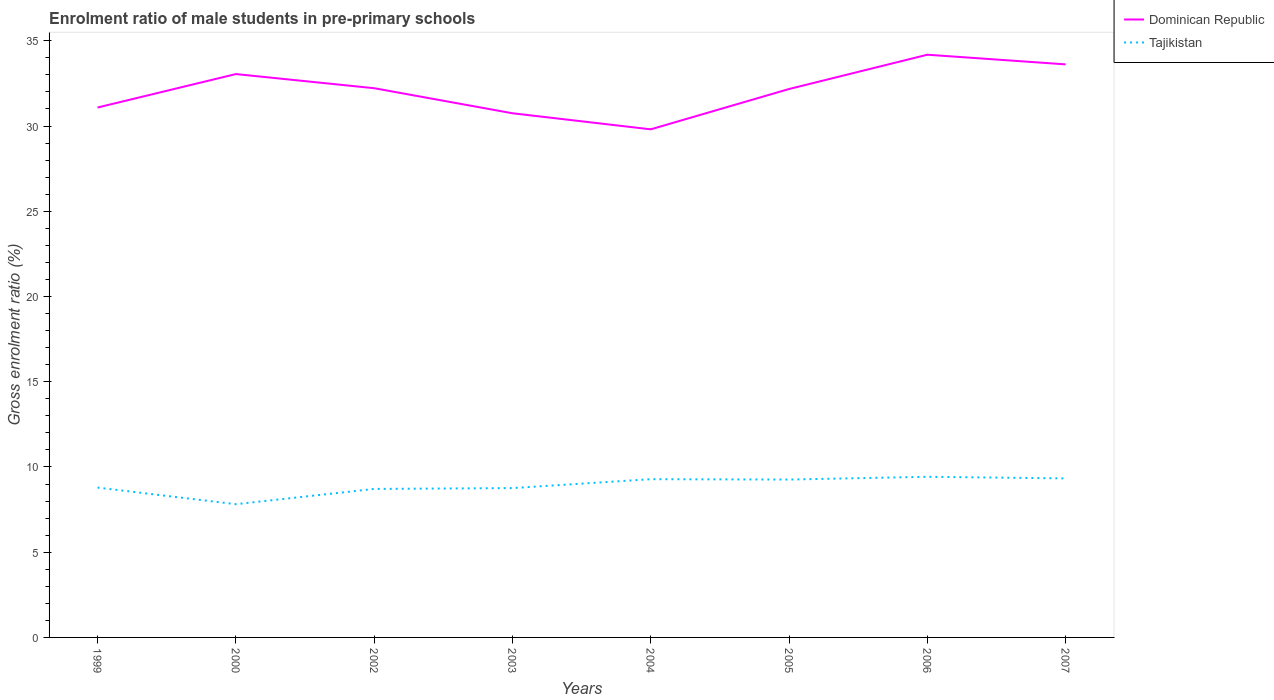Is the number of lines equal to the number of legend labels?
Provide a short and direct response. Yes. Across all years, what is the maximum enrolment ratio of male students in pre-primary schools in Tajikistan?
Offer a terse response. 7.82. What is the total enrolment ratio of male students in pre-primary schools in Dominican Republic in the graph?
Ensure brevity in your answer.  -2.01. What is the difference between the highest and the second highest enrolment ratio of male students in pre-primary schools in Tajikistan?
Keep it short and to the point. 1.61. What is the difference between the highest and the lowest enrolment ratio of male students in pre-primary schools in Dominican Republic?
Your answer should be compact. 5. Is the enrolment ratio of male students in pre-primary schools in Tajikistan strictly greater than the enrolment ratio of male students in pre-primary schools in Dominican Republic over the years?
Ensure brevity in your answer.  Yes. How many years are there in the graph?
Keep it short and to the point. 8. Does the graph contain grids?
Make the answer very short. No. How many legend labels are there?
Your answer should be compact. 2. What is the title of the graph?
Your response must be concise. Enrolment ratio of male students in pre-primary schools. Does "Bahamas" appear as one of the legend labels in the graph?
Offer a terse response. No. What is the Gross enrolment ratio (%) of Dominican Republic in 1999?
Your response must be concise. 31.09. What is the Gross enrolment ratio (%) of Tajikistan in 1999?
Your response must be concise. 8.79. What is the Gross enrolment ratio (%) in Dominican Republic in 2000?
Your answer should be very brief. 33.05. What is the Gross enrolment ratio (%) of Tajikistan in 2000?
Make the answer very short. 7.82. What is the Gross enrolment ratio (%) in Dominican Republic in 2002?
Offer a terse response. 32.22. What is the Gross enrolment ratio (%) in Tajikistan in 2002?
Offer a very short reply. 8.71. What is the Gross enrolment ratio (%) of Dominican Republic in 2003?
Ensure brevity in your answer.  30.75. What is the Gross enrolment ratio (%) of Tajikistan in 2003?
Ensure brevity in your answer.  8.76. What is the Gross enrolment ratio (%) in Dominican Republic in 2004?
Your answer should be very brief. 29.81. What is the Gross enrolment ratio (%) of Tajikistan in 2004?
Ensure brevity in your answer.  9.28. What is the Gross enrolment ratio (%) of Dominican Republic in 2005?
Offer a terse response. 32.17. What is the Gross enrolment ratio (%) of Tajikistan in 2005?
Your answer should be compact. 9.26. What is the Gross enrolment ratio (%) in Dominican Republic in 2006?
Your response must be concise. 34.18. What is the Gross enrolment ratio (%) in Tajikistan in 2006?
Provide a succinct answer. 9.42. What is the Gross enrolment ratio (%) of Dominican Republic in 2007?
Keep it short and to the point. 33.62. What is the Gross enrolment ratio (%) in Tajikistan in 2007?
Give a very brief answer. 9.33. Across all years, what is the maximum Gross enrolment ratio (%) of Dominican Republic?
Keep it short and to the point. 34.18. Across all years, what is the maximum Gross enrolment ratio (%) of Tajikistan?
Your response must be concise. 9.42. Across all years, what is the minimum Gross enrolment ratio (%) in Dominican Republic?
Make the answer very short. 29.81. Across all years, what is the minimum Gross enrolment ratio (%) of Tajikistan?
Your response must be concise. 7.82. What is the total Gross enrolment ratio (%) in Dominican Republic in the graph?
Offer a terse response. 256.88. What is the total Gross enrolment ratio (%) in Tajikistan in the graph?
Offer a very short reply. 71.37. What is the difference between the Gross enrolment ratio (%) in Dominican Republic in 1999 and that in 2000?
Your answer should be very brief. -1.96. What is the difference between the Gross enrolment ratio (%) in Tajikistan in 1999 and that in 2000?
Ensure brevity in your answer.  0.97. What is the difference between the Gross enrolment ratio (%) of Dominican Republic in 1999 and that in 2002?
Your response must be concise. -1.13. What is the difference between the Gross enrolment ratio (%) of Tajikistan in 1999 and that in 2002?
Offer a terse response. 0.08. What is the difference between the Gross enrolment ratio (%) of Dominican Republic in 1999 and that in 2003?
Your response must be concise. 0.34. What is the difference between the Gross enrolment ratio (%) of Tajikistan in 1999 and that in 2003?
Provide a short and direct response. 0.03. What is the difference between the Gross enrolment ratio (%) of Dominican Republic in 1999 and that in 2004?
Your answer should be compact. 1.28. What is the difference between the Gross enrolment ratio (%) of Tajikistan in 1999 and that in 2004?
Provide a short and direct response. -0.49. What is the difference between the Gross enrolment ratio (%) of Dominican Republic in 1999 and that in 2005?
Make the answer very short. -1.09. What is the difference between the Gross enrolment ratio (%) in Tajikistan in 1999 and that in 2005?
Provide a succinct answer. -0.47. What is the difference between the Gross enrolment ratio (%) of Dominican Republic in 1999 and that in 2006?
Offer a terse response. -3.1. What is the difference between the Gross enrolment ratio (%) of Tajikistan in 1999 and that in 2006?
Provide a succinct answer. -0.63. What is the difference between the Gross enrolment ratio (%) of Dominican Republic in 1999 and that in 2007?
Ensure brevity in your answer.  -2.53. What is the difference between the Gross enrolment ratio (%) of Tajikistan in 1999 and that in 2007?
Offer a terse response. -0.54. What is the difference between the Gross enrolment ratio (%) in Dominican Republic in 2000 and that in 2002?
Offer a terse response. 0.83. What is the difference between the Gross enrolment ratio (%) of Tajikistan in 2000 and that in 2002?
Offer a very short reply. -0.9. What is the difference between the Gross enrolment ratio (%) of Dominican Republic in 2000 and that in 2003?
Keep it short and to the point. 2.3. What is the difference between the Gross enrolment ratio (%) of Tajikistan in 2000 and that in 2003?
Offer a very short reply. -0.94. What is the difference between the Gross enrolment ratio (%) in Dominican Republic in 2000 and that in 2004?
Give a very brief answer. 3.24. What is the difference between the Gross enrolment ratio (%) of Tajikistan in 2000 and that in 2004?
Give a very brief answer. -1.47. What is the difference between the Gross enrolment ratio (%) in Dominican Republic in 2000 and that in 2005?
Ensure brevity in your answer.  0.88. What is the difference between the Gross enrolment ratio (%) of Tajikistan in 2000 and that in 2005?
Ensure brevity in your answer.  -1.45. What is the difference between the Gross enrolment ratio (%) of Dominican Republic in 2000 and that in 2006?
Provide a succinct answer. -1.14. What is the difference between the Gross enrolment ratio (%) in Tajikistan in 2000 and that in 2006?
Offer a terse response. -1.61. What is the difference between the Gross enrolment ratio (%) of Dominican Republic in 2000 and that in 2007?
Your response must be concise. -0.57. What is the difference between the Gross enrolment ratio (%) in Tajikistan in 2000 and that in 2007?
Offer a terse response. -1.51. What is the difference between the Gross enrolment ratio (%) in Dominican Republic in 2002 and that in 2003?
Give a very brief answer. 1.47. What is the difference between the Gross enrolment ratio (%) in Tajikistan in 2002 and that in 2003?
Provide a short and direct response. -0.05. What is the difference between the Gross enrolment ratio (%) of Dominican Republic in 2002 and that in 2004?
Give a very brief answer. 2.41. What is the difference between the Gross enrolment ratio (%) of Tajikistan in 2002 and that in 2004?
Keep it short and to the point. -0.57. What is the difference between the Gross enrolment ratio (%) in Dominican Republic in 2002 and that in 2005?
Your answer should be very brief. 0.05. What is the difference between the Gross enrolment ratio (%) in Tajikistan in 2002 and that in 2005?
Offer a terse response. -0.55. What is the difference between the Gross enrolment ratio (%) of Dominican Republic in 2002 and that in 2006?
Your answer should be compact. -1.96. What is the difference between the Gross enrolment ratio (%) in Tajikistan in 2002 and that in 2006?
Keep it short and to the point. -0.71. What is the difference between the Gross enrolment ratio (%) of Dominican Republic in 2002 and that in 2007?
Offer a terse response. -1.4. What is the difference between the Gross enrolment ratio (%) in Tajikistan in 2002 and that in 2007?
Your response must be concise. -0.62. What is the difference between the Gross enrolment ratio (%) in Dominican Republic in 2003 and that in 2004?
Offer a terse response. 0.94. What is the difference between the Gross enrolment ratio (%) of Tajikistan in 2003 and that in 2004?
Give a very brief answer. -0.52. What is the difference between the Gross enrolment ratio (%) in Dominican Republic in 2003 and that in 2005?
Your response must be concise. -1.42. What is the difference between the Gross enrolment ratio (%) in Tajikistan in 2003 and that in 2005?
Ensure brevity in your answer.  -0.5. What is the difference between the Gross enrolment ratio (%) in Dominican Republic in 2003 and that in 2006?
Offer a very short reply. -3.43. What is the difference between the Gross enrolment ratio (%) of Tajikistan in 2003 and that in 2006?
Offer a terse response. -0.66. What is the difference between the Gross enrolment ratio (%) in Dominican Republic in 2003 and that in 2007?
Make the answer very short. -2.87. What is the difference between the Gross enrolment ratio (%) in Tajikistan in 2003 and that in 2007?
Make the answer very short. -0.57. What is the difference between the Gross enrolment ratio (%) in Dominican Republic in 2004 and that in 2005?
Your answer should be compact. -2.37. What is the difference between the Gross enrolment ratio (%) of Tajikistan in 2004 and that in 2005?
Your answer should be very brief. 0.02. What is the difference between the Gross enrolment ratio (%) of Dominican Republic in 2004 and that in 2006?
Keep it short and to the point. -4.38. What is the difference between the Gross enrolment ratio (%) of Tajikistan in 2004 and that in 2006?
Provide a short and direct response. -0.14. What is the difference between the Gross enrolment ratio (%) in Dominican Republic in 2004 and that in 2007?
Give a very brief answer. -3.81. What is the difference between the Gross enrolment ratio (%) of Tajikistan in 2004 and that in 2007?
Provide a short and direct response. -0.05. What is the difference between the Gross enrolment ratio (%) of Dominican Republic in 2005 and that in 2006?
Your answer should be compact. -2.01. What is the difference between the Gross enrolment ratio (%) of Tajikistan in 2005 and that in 2006?
Give a very brief answer. -0.16. What is the difference between the Gross enrolment ratio (%) in Dominican Republic in 2005 and that in 2007?
Make the answer very short. -1.45. What is the difference between the Gross enrolment ratio (%) of Tajikistan in 2005 and that in 2007?
Ensure brevity in your answer.  -0.07. What is the difference between the Gross enrolment ratio (%) in Dominican Republic in 2006 and that in 2007?
Your answer should be very brief. 0.57. What is the difference between the Gross enrolment ratio (%) in Tajikistan in 2006 and that in 2007?
Give a very brief answer. 0.09. What is the difference between the Gross enrolment ratio (%) in Dominican Republic in 1999 and the Gross enrolment ratio (%) in Tajikistan in 2000?
Provide a short and direct response. 23.27. What is the difference between the Gross enrolment ratio (%) in Dominican Republic in 1999 and the Gross enrolment ratio (%) in Tajikistan in 2002?
Your response must be concise. 22.37. What is the difference between the Gross enrolment ratio (%) in Dominican Republic in 1999 and the Gross enrolment ratio (%) in Tajikistan in 2003?
Keep it short and to the point. 22.33. What is the difference between the Gross enrolment ratio (%) in Dominican Republic in 1999 and the Gross enrolment ratio (%) in Tajikistan in 2004?
Make the answer very short. 21.8. What is the difference between the Gross enrolment ratio (%) in Dominican Republic in 1999 and the Gross enrolment ratio (%) in Tajikistan in 2005?
Provide a succinct answer. 21.82. What is the difference between the Gross enrolment ratio (%) of Dominican Republic in 1999 and the Gross enrolment ratio (%) of Tajikistan in 2006?
Provide a succinct answer. 21.66. What is the difference between the Gross enrolment ratio (%) of Dominican Republic in 1999 and the Gross enrolment ratio (%) of Tajikistan in 2007?
Your answer should be very brief. 21.76. What is the difference between the Gross enrolment ratio (%) of Dominican Republic in 2000 and the Gross enrolment ratio (%) of Tajikistan in 2002?
Your response must be concise. 24.34. What is the difference between the Gross enrolment ratio (%) in Dominican Republic in 2000 and the Gross enrolment ratio (%) in Tajikistan in 2003?
Offer a very short reply. 24.29. What is the difference between the Gross enrolment ratio (%) in Dominican Republic in 2000 and the Gross enrolment ratio (%) in Tajikistan in 2004?
Offer a very short reply. 23.77. What is the difference between the Gross enrolment ratio (%) in Dominican Republic in 2000 and the Gross enrolment ratio (%) in Tajikistan in 2005?
Keep it short and to the point. 23.79. What is the difference between the Gross enrolment ratio (%) of Dominican Republic in 2000 and the Gross enrolment ratio (%) of Tajikistan in 2006?
Offer a very short reply. 23.62. What is the difference between the Gross enrolment ratio (%) of Dominican Republic in 2000 and the Gross enrolment ratio (%) of Tajikistan in 2007?
Make the answer very short. 23.72. What is the difference between the Gross enrolment ratio (%) of Dominican Republic in 2002 and the Gross enrolment ratio (%) of Tajikistan in 2003?
Your answer should be very brief. 23.46. What is the difference between the Gross enrolment ratio (%) of Dominican Republic in 2002 and the Gross enrolment ratio (%) of Tajikistan in 2004?
Make the answer very short. 22.94. What is the difference between the Gross enrolment ratio (%) of Dominican Republic in 2002 and the Gross enrolment ratio (%) of Tajikistan in 2005?
Offer a terse response. 22.96. What is the difference between the Gross enrolment ratio (%) of Dominican Republic in 2002 and the Gross enrolment ratio (%) of Tajikistan in 2006?
Your answer should be compact. 22.8. What is the difference between the Gross enrolment ratio (%) of Dominican Republic in 2002 and the Gross enrolment ratio (%) of Tajikistan in 2007?
Your response must be concise. 22.89. What is the difference between the Gross enrolment ratio (%) of Dominican Republic in 2003 and the Gross enrolment ratio (%) of Tajikistan in 2004?
Your answer should be compact. 21.47. What is the difference between the Gross enrolment ratio (%) in Dominican Republic in 2003 and the Gross enrolment ratio (%) in Tajikistan in 2005?
Your response must be concise. 21.49. What is the difference between the Gross enrolment ratio (%) of Dominican Republic in 2003 and the Gross enrolment ratio (%) of Tajikistan in 2006?
Offer a very short reply. 21.32. What is the difference between the Gross enrolment ratio (%) of Dominican Republic in 2003 and the Gross enrolment ratio (%) of Tajikistan in 2007?
Make the answer very short. 21.42. What is the difference between the Gross enrolment ratio (%) of Dominican Republic in 2004 and the Gross enrolment ratio (%) of Tajikistan in 2005?
Keep it short and to the point. 20.54. What is the difference between the Gross enrolment ratio (%) in Dominican Republic in 2004 and the Gross enrolment ratio (%) in Tajikistan in 2006?
Offer a terse response. 20.38. What is the difference between the Gross enrolment ratio (%) in Dominican Republic in 2004 and the Gross enrolment ratio (%) in Tajikistan in 2007?
Your response must be concise. 20.48. What is the difference between the Gross enrolment ratio (%) in Dominican Republic in 2005 and the Gross enrolment ratio (%) in Tajikistan in 2006?
Offer a very short reply. 22.75. What is the difference between the Gross enrolment ratio (%) in Dominican Republic in 2005 and the Gross enrolment ratio (%) in Tajikistan in 2007?
Keep it short and to the point. 22.84. What is the difference between the Gross enrolment ratio (%) in Dominican Republic in 2006 and the Gross enrolment ratio (%) in Tajikistan in 2007?
Your response must be concise. 24.85. What is the average Gross enrolment ratio (%) in Dominican Republic per year?
Make the answer very short. 32.11. What is the average Gross enrolment ratio (%) of Tajikistan per year?
Ensure brevity in your answer.  8.92. In the year 1999, what is the difference between the Gross enrolment ratio (%) in Dominican Republic and Gross enrolment ratio (%) in Tajikistan?
Your answer should be very brief. 22.3. In the year 2000, what is the difference between the Gross enrolment ratio (%) in Dominican Republic and Gross enrolment ratio (%) in Tajikistan?
Offer a very short reply. 25.23. In the year 2002, what is the difference between the Gross enrolment ratio (%) in Dominican Republic and Gross enrolment ratio (%) in Tajikistan?
Keep it short and to the point. 23.51. In the year 2003, what is the difference between the Gross enrolment ratio (%) of Dominican Republic and Gross enrolment ratio (%) of Tajikistan?
Your answer should be compact. 21.99. In the year 2004, what is the difference between the Gross enrolment ratio (%) in Dominican Republic and Gross enrolment ratio (%) in Tajikistan?
Give a very brief answer. 20.52. In the year 2005, what is the difference between the Gross enrolment ratio (%) in Dominican Republic and Gross enrolment ratio (%) in Tajikistan?
Your answer should be compact. 22.91. In the year 2006, what is the difference between the Gross enrolment ratio (%) in Dominican Republic and Gross enrolment ratio (%) in Tajikistan?
Your response must be concise. 24.76. In the year 2007, what is the difference between the Gross enrolment ratio (%) of Dominican Republic and Gross enrolment ratio (%) of Tajikistan?
Your response must be concise. 24.29. What is the ratio of the Gross enrolment ratio (%) in Dominican Republic in 1999 to that in 2000?
Give a very brief answer. 0.94. What is the ratio of the Gross enrolment ratio (%) in Tajikistan in 1999 to that in 2000?
Give a very brief answer. 1.12. What is the ratio of the Gross enrolment ratio (%) in Dominican Republic in 1999 to that in 2002?
Provide a short and direct response. 0.96. What is the ratio of the Gross enrolment ratio (%) of Tajikistan in 1999 to that in 2002?
Your answer should be compact. 1.01. What is the ratio of the Gross enrolment ratio (%) of Dominican Republic in 1999 to that in 2003?
Offer a terse response. 1.01. What is the ratio of the Gross enrolment ratio (%) in Tajikistan in 1999 to that in 2003?
Make the answer very short. 1. What is the ratio of the Gross enrolment ratio (%) in Dominican Republic in 1999 to that in 2004?
Give a very brief answer. 1.04. What is the ratio of the Gross enrolment ratio (%) of Tajikistan in 1999 to that in 2004?
Give a very brief answer. 0.95. What is the ratio of the Gross enrolment ratio (%) of Dominican Republic in 1999 to that in 2005?
Your answer should be very brief. 0.97. What is the ratio of the Gross enrolment ratio (%) of Tajikistan in 1999 to that in 2005?
Provide a succinct answer. 0.95. What is the ratio of the Gross enrolment ratio (%) in Dominican Republic in 1999 to that in 2006?
Offer a terse response. 0.91. What is the ratio of the Gross enrolment ratio (%) in Tajikistan in 1999 to that in 2006?
Give a very brief answer. 0.93. What is the ratio of the Gross enrolment ratio (%) of Dominican Republic in 1999 to that in 2007?
Offer a very short reply. 0.92. What is the ratio of the Gross enrolment ratio (%) in Tajikistan in 1999 to that in 2007?
Your answer should be compact. 0.94. What is the ratio of the Gross enrolment ratio (%) of Dominican Republic in 2000 to that in 2002?
Offer a very short reply. 1.03. What is the ratio of the Gross enrolment ratio (%) of Tajikistan in 2000 to that in 2002?
Your answer should be compact. 0.9. What is the ratio of the Gross enrolment ratio (%) of Dominican Republic in 2000 to that in 2003?
Make the answer very short. 1.07. What is the ratio of the Gross enrolment ratio (%) in Tajikistan in 2000 to that in 2003?
Provide a short and direct response. 0.89. What is the ratio of the Gross enrolment ratio (%) of Dominican Republic in 2000 to that in 2004?
Offer a terse response. 1.11. What is the ratio of the Gross enrolment ratio (%) of Tajikistan in 2000 to that in 2004?
Ensure brevity in your answer.  0.84. What is the ratio of the Gross enrolment ratio (%) in Dominican Republic in 2000 to that in 2005?
Your answer should be compact. 1.03. What is the ratio of the Gross enrolment ratio (%) in Tajikistan in 2000 to that in 2005?
Keep it short and to the point. 0.84. What is the ratio of the Gross enrolment ratio (%) of Dominican Republic in 2000 to that in 2006?
Provide a short and direct response. 0.97. What is the ratio of the Gross enrolment ratio (%) of Tajikistan in 2000 to that in 2006?
Your response must be concise. 0.83. What is the ratio of the Gross enrolment ratio (%) in Dominican Republic in 2000 to that in 2007?
Your answer should be compact. 0.98. What is the ratio of the Gross enrolment ratio (%) of Tajikistan in 2000 to that in 2007?
Your response must be concise. 0.84. What is the ratio of the Gross enrolment ratio (%) of Dominican Republic in 2002 to that in 2003?
Provide a succinct answer. 1.05. What is the ratio of the Gross enrolment ratio (%) of Tajikistan in 2002 to that in 2003?
Provide a succinct answer. 0.99. What is the ratio of the Gross enrolment ratio (%) in Dominican Republic in 2002 to that in 2004?
Keep it short and to the point. 1.08. What is the ratio of the Gross enrolment ratio (%) of Tajikistan in 2002 to that in 2004?
Offer a terse response. 0.94. What is the ratio of the Gross enrolment ratio (%) in Tajikistan in 2002 to that in 2005?
Keep it short and to the point. 0.94. What is the ratio of the Gross enrolment ratio (%) of Dominican Republic in 2002 to that in 2006?
Give a very brief answer. 0.94. What is the ratio of the Gross enrolment ratio (%) of Tajikistan in 2002 to that in 2006?
Your answer should be very brief. 0.92. What is the ratio of the Gross enrolment ratio (%) of Dominican Republic in 2002 to that in 2007?
Provide a succinct answer. 0.96. What is the ratio of the Gross enrolment ratio (%) of Tajikistan in 2002 to that in 2007?
Provide a short and direct response. 0.93. What is the ratio of the Gross enrolment ratio (%) of Dominican Republic in 2003 to that in 2004?
Provide a succinct answer. 1.03. What is the ratio of the Gross enrolment ratio (%) of Tajikistan in 2003 to that in 2004?
Provide a short and direct response. 0.94. What is the ratio of the Gross enrolment ratio (%) of Dominican Republic in 2003 to that in 2005?
Provide a short and direct response. 0.96. What is the ratio of the Gross enrolment ratio (%) of Tajikistan in 2003 to that in 2005?
Your response must be concise. 0.95. What is the ratio of the Gross enrolment ratio (%) of Dominican Republic in 2003 to that in 2006?
Give a very brief answer. 0.9. What is the ratio of the Gross enrolment ratio (%) in Tajikistan in 2003 to that in 2006?
Ensure brevity in your answer.  0.93. What is the ratio of the Gross enrolment ratio (%) in Dominican Republic in 2003 to that in 2007?
Your response must be concise. 0.91. What is the ratio of the Gross enrolment ratio (%) in Tajikistan in 2003 to that in 2007?
Provide a short and direct response. 0.94. What is the ratio of the Gross enrolment ratio (%) of Dominican Republic in 2004 to that in 2005?
Keep it short and to the point. 0.93. What is the ratio of the Gross enrolment ratio (%) in Tajikistan in 2004 to that in 2005?
Offer a terse response. 1. What is the ratio of the Gross enrolment ratio (%) of Dominican Republic in 2004 to that in 2006?
Offer a terse response. 0.87. What is the ratio of the Gross enrolment ratio (%) in Tajikistan in 2004 to that in 2006?
Give a very brief answer. 0.98. What is the ratio of the Gross enrolment ratio (%) in Dominican Republic in 2004 to that in 2007?
Offer a very short reply. 0.89. What is the ratio of the Gross enrolment ratio (%) in Tajikistan in 2005 to that in 2006?
Your response must be concise. 0.98. What is the ratio of the Gross enrolment ratio (%) in Dominican Republic in 2006 to that in 2007?
Provide a short and direct response. 1.02. What is the difference between the highest and the second highest Gross enrolment ratio (%) of Dominican Republic?
Provide a short and direct response. 0.57. What is the difference between the highest and the second highest Gross enrolment ratio (%) in Tajikistan?
Offer a terse response. 0.09. What is the difference between the highest and the lowest Gross enrolment ratio (%) in Dominican Republic?
Your response must be concise. 4.38. What is the difference between the highest and the lowest Gross enrolment ratio (%) in Tajikistan?
Offer a very short reply. 1.61. 